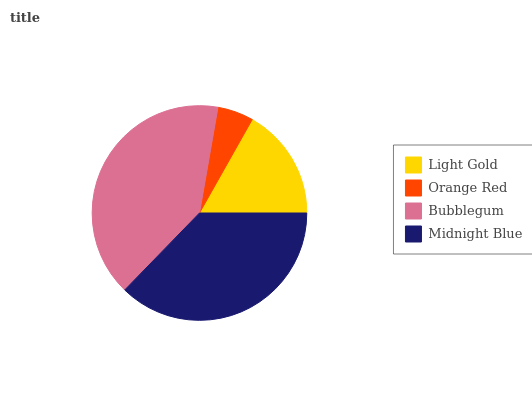Is Orange Red the minimum?
Answer yes or no. Yes. Is Bubblegum the maximum?
Answer yes or no. Yes. Is Bubblegum the minimum?
Answer yes or no. No. Is Orange Red the maximum?
Answer yes or no. No. Is Bubblegum greater than Orange Red?
Answer yes or no. Yes. Is Orange Red less than Bubblegum?
Answer yes or no. Yes. Is Orange Red greater than Bubblegum?
Answer yes or no. No. Is Bubblegum less than Orange Red?
Answer yes or no. No. Is Midnight Blue the high median?
Answer yes or no. Yes. Is Light Gold the low median?
Answer yes or no. Yes. Is Light Gold the high median?
Answer yes or no. No. Is Bubblegum the low median?
Answer yes or no. No. 